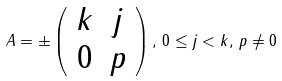Convert formula to latex. <formula><loc_0><loc_0><loc_500><loc_500>A = \pm \left ( \begin{array} { c c } k & j \\ 0 & p \end{array} \right ) , \, 0 \leq j < k , \, p \neq 0</formula> 